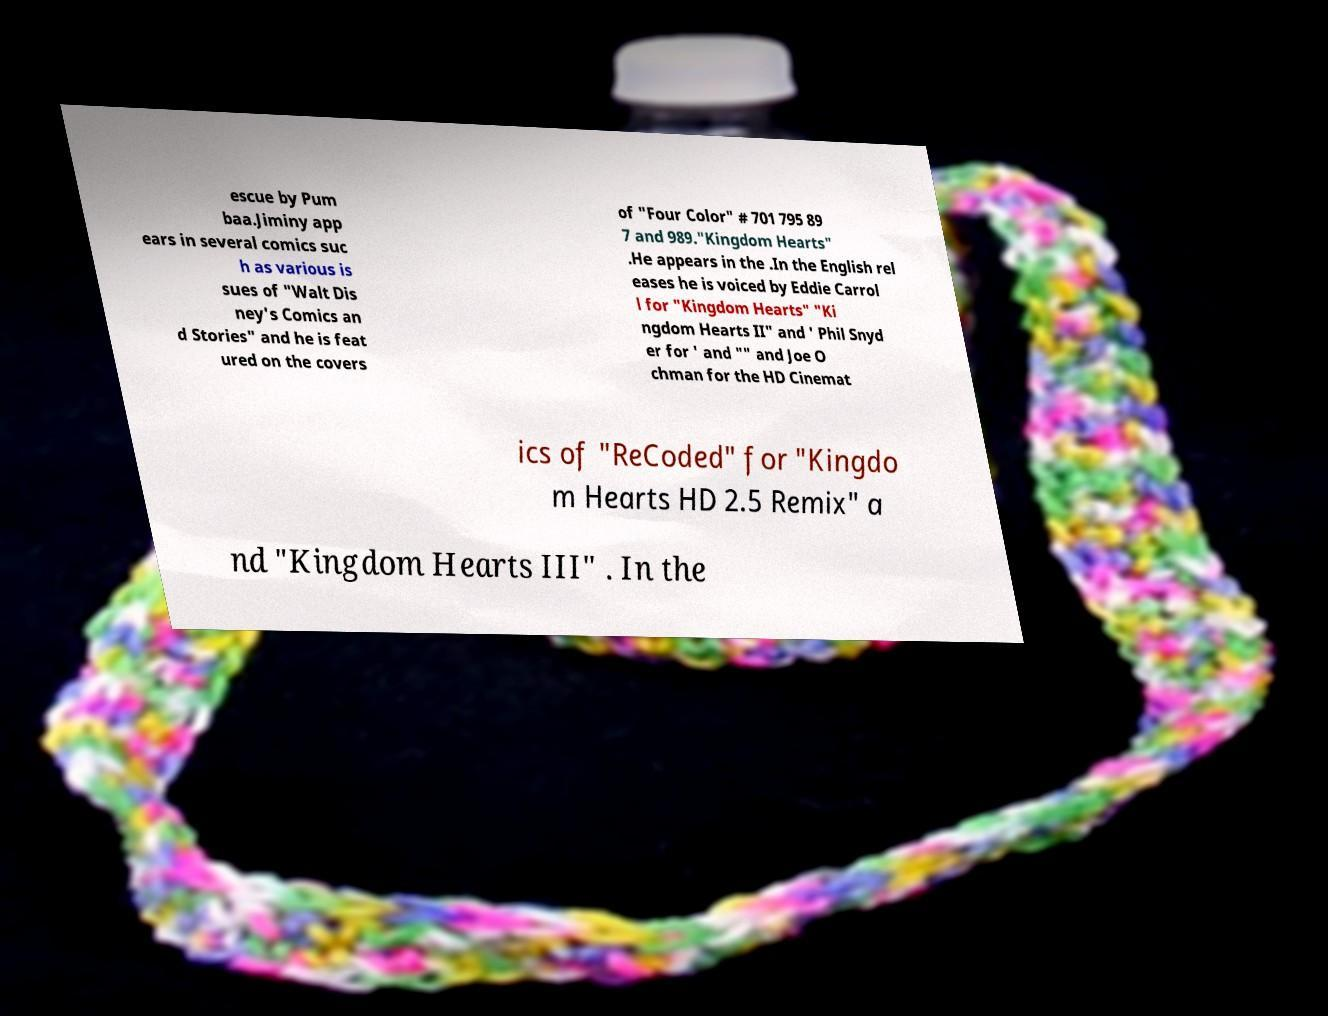I need the written content from this picture converted into text. Can you do that? escue by Pum baa.Jiminy app ears in several comics suc h as various is sues of "Walt Dis ney's Comics an d Stories" and he is feat ured on the covers of "Four Color" # 701 795 89 7 and 989."Kingdom Hearts" .He appears in the .In the English rel eases he is voiced by Eddie Carrol l for "Kingdom Hearts" "Ki ngdom Hearts II" and ' Phil Snyd er for ' and "" and Joe O chman for the HD Cinemat ics of "ReCoded" for "Kingdo m Hearts HD 2.5 Remix" a nd "Kingdom Hearts III" . In the 